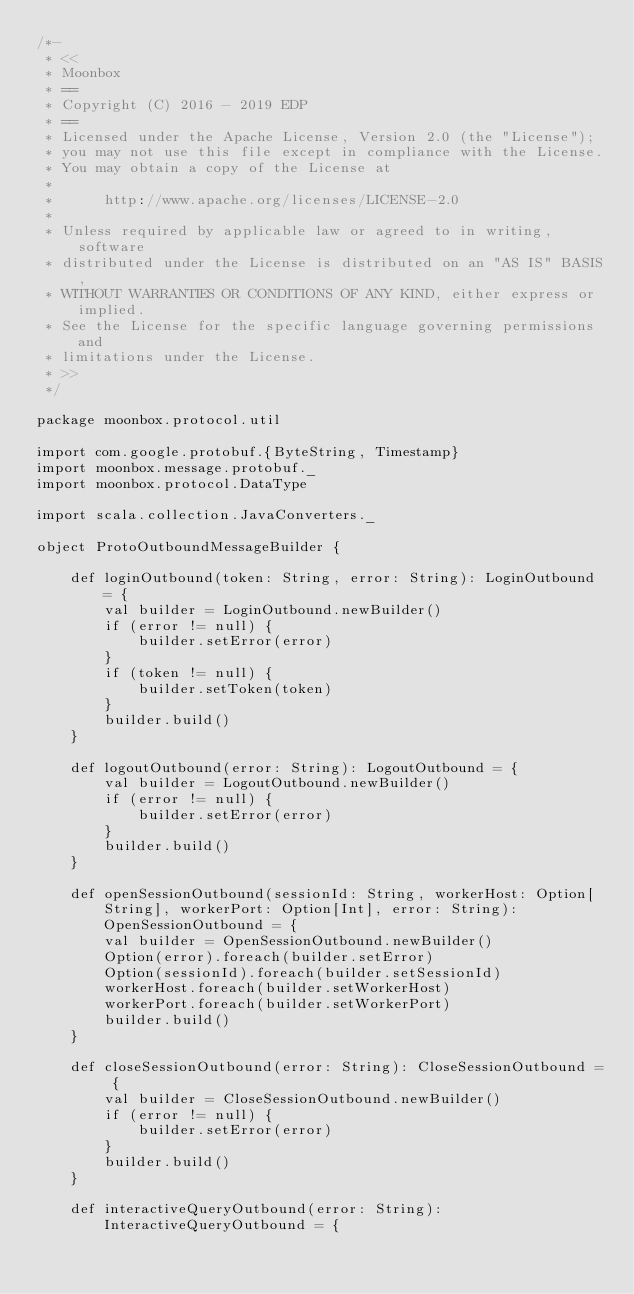Convert code to text. <code><loc_0><loc_0><loc_500><loc_500><_Scala_>/*-
 * <<
 * Moonbox
 * ==
 * Copyright (C) 2016 - 2019 EDP
 * ==
 * Licensed under the Apache License, Version 2.0 (the "License");
 * you may not use this file except in compliance with the License.
 * You may obtain a copy of the License at
 * 
 *      http://www.apache.org/licenses/LICENSE-2.0
 * 
 * Unless required by applicable law or agreed to in writing, software
 * distributed under the License is distributed on an "AS IS" BASIS,
 * WITHOUT WARRANTIES OR CONDITIONS OF ANY KIND, either express or implied.
 * See the License for the specific language governing permissions and
 * limitations under the License.
 * >>
 */

package moonbox.protocol.util

import com.google.protobuf.{ByteString, Timestamp}
import moonbox.message.protobuf._
import moonbox.protocol.DataType

import scala.collection.JavaConverters._

object ProtoOutboundMessageBuilder {

	def loginOutbound(token: String, error: String): LoginOutbound = {
		val builder = LoginOutbound.newBuilder()
		if (error != null) {
			builder.setError(error)
		}
		if (token != null) {
			builder.setToken(token)
		}
		builder.build()
	}

	def logoutOutbound(error: String): LogoutOutbound = {
		val builder = LogoutOutbound.newBuilder()
		if (error != null) {
			builder.setError(error)
		}
		builder.build()
	}

	def openSessionOutbound(sessionId: String, workerHost: Option[String], workerPort: Option[Int], error: String): OpenSessionOutbound = {
		val builder = OpenSessionOutbound.newBuilder()
		Option(error).foreach(builder.setError)
		Option(sessionId).foreach(builder.setSessionId)
		workerHost.foreach(builder.setWorkerHost)
		workerPort.foreach(builder.setWorkerPort)
		builder.build()
	}

	def closeSessionOutbound(error: String): CloseSessionOutbound = {
		val builder = CloseSessionOutbound.newBuilder()
		if (error != null) {
			builder.setError(error)
		}
		builder.build()
	}

	def interactiveQueryOutbound(error: String): InteractiveQueryOutbound = {</code> 